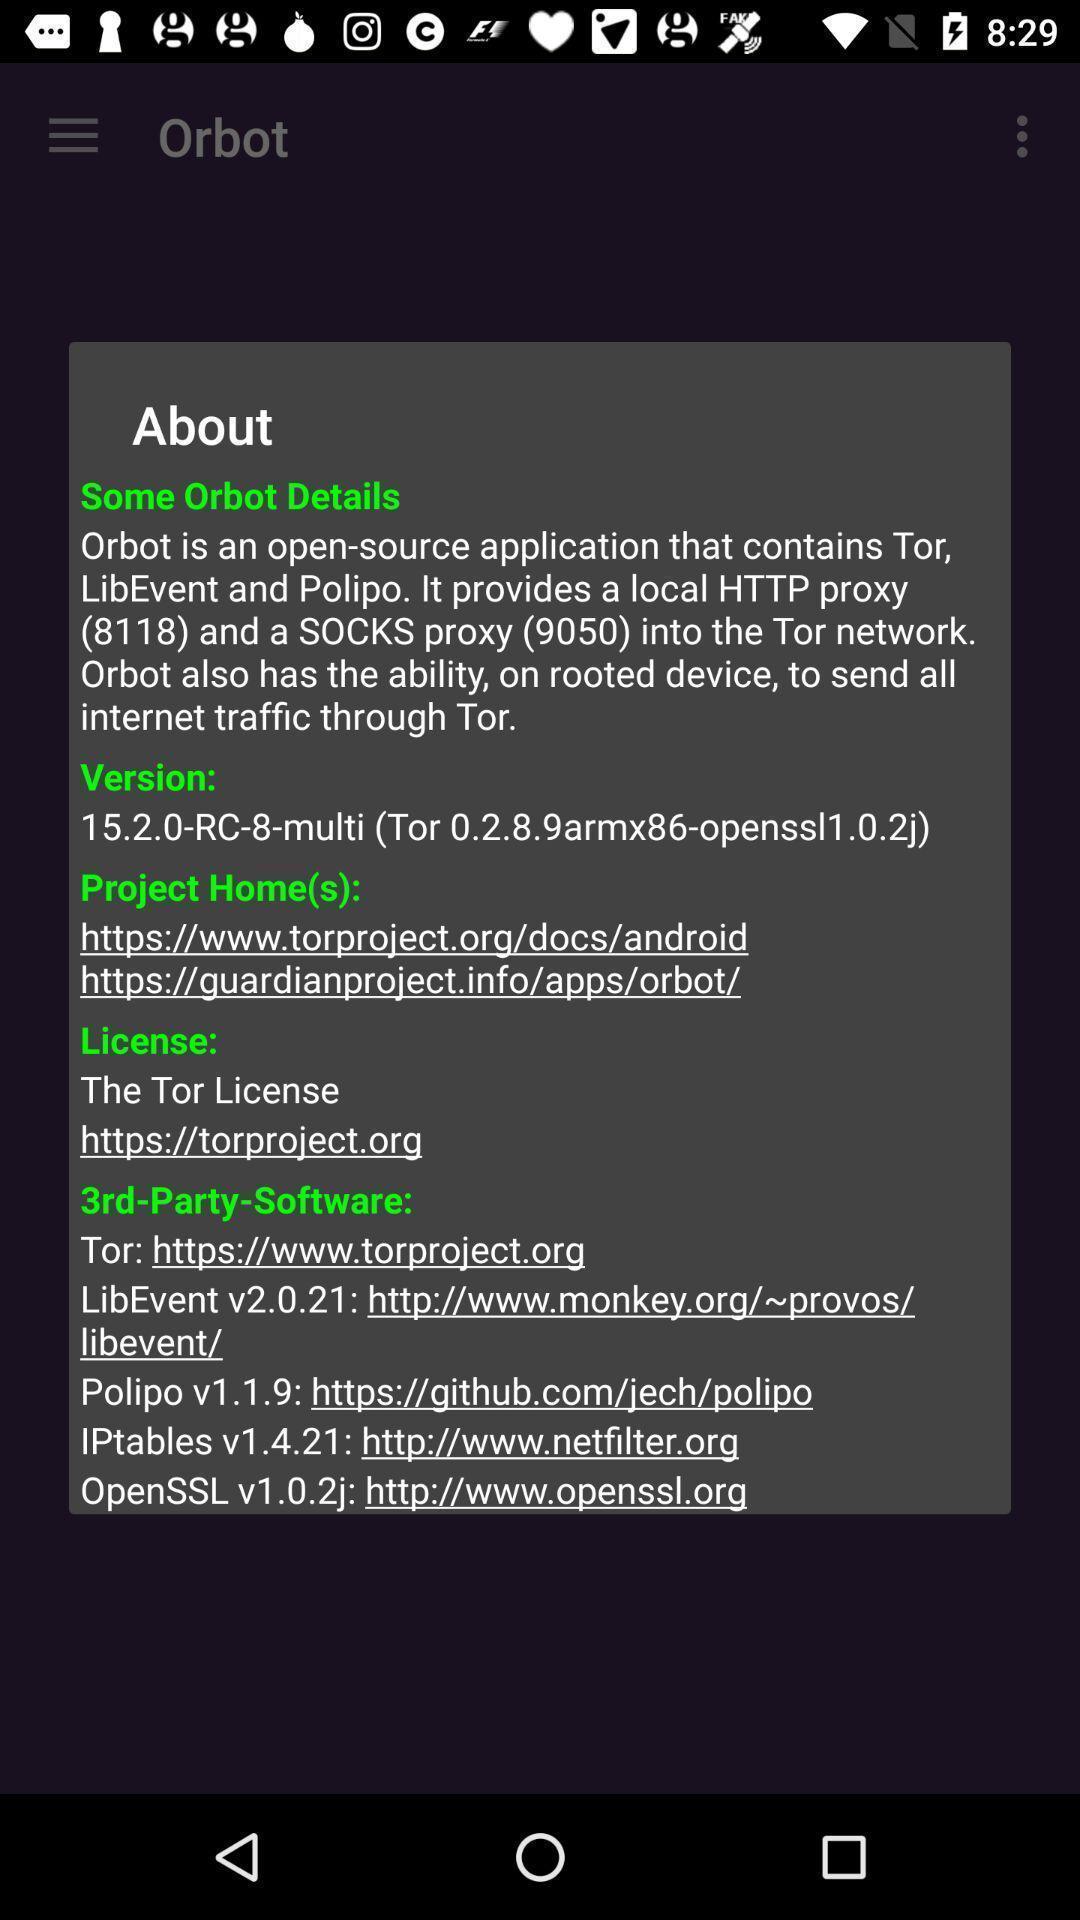Give me a summary of this screen capture. Pop-up shows about details. 